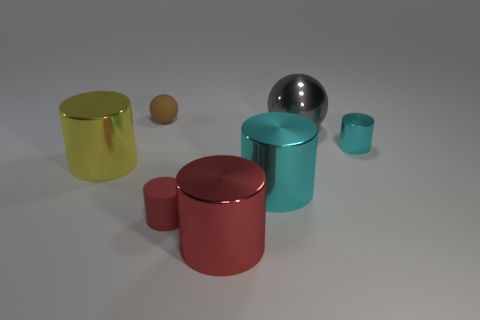Subtract all tiny shiny cylinders. How many cylinders are left? 4 Subtract all yellow cylinders. How many cylinders are left? 4 Subtract all brown cylinders. Subtract all blue blocks. How many cylinders are left? 5 Add 2 small rubber things. How many objects exist? 9 Subtract all cylinders. How many objects are left? 2 Subtract 0 red balls. How many objects are left? 7 Subtract all big gray metallic things. Subtract all big brown rubber blocks. How many objects are left? 6 Add 6 metal spheres. How many metal spheres are left? 7 Add 2 big gray spheres. How many big gray spheres exist? 3 